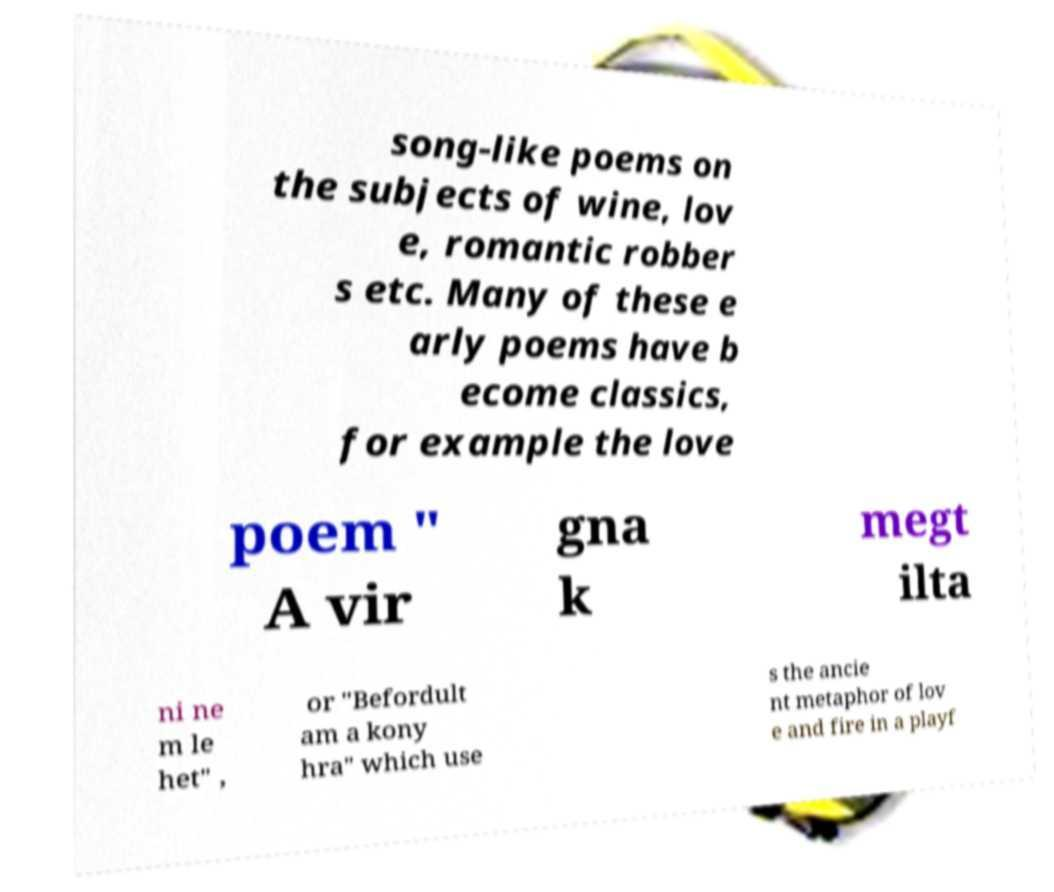Can you accurately transcribe the text from the provided image for me? song-like poems on the subjects of wine, lov e, romantic robber s etc. Many of these e arly poems have b ecome classics, for example the love poem " A vir gna k megt ilta ni ne m le het" , or "Befordult am a kony hra" which use s the ancie nt metaphor of lov e and fire in a playf 